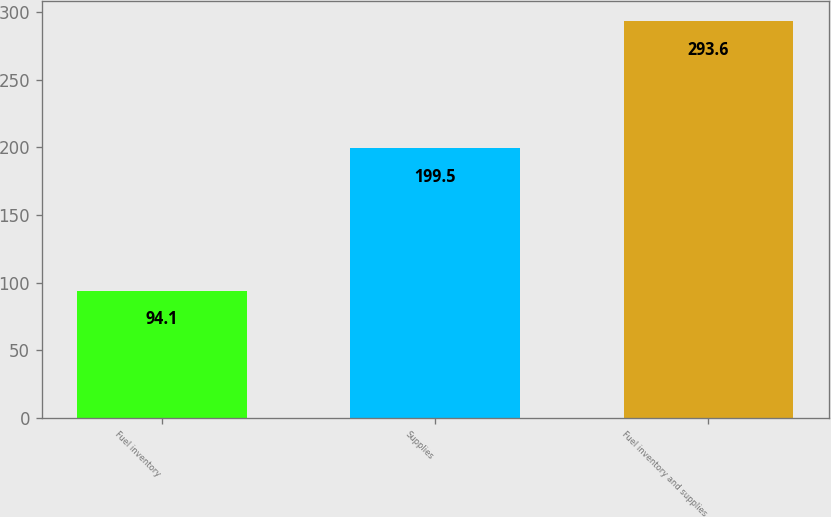Convert chart. <chart><loc_0><loc_0><loc_500><loc_500><bar_chart><fcel>Fuel inventory<fcel>Supplies<fcel>Fuel inventory and supplies<nl><fcel>94.1<fcel>199.5<fcel>293.6<nl></chart> 